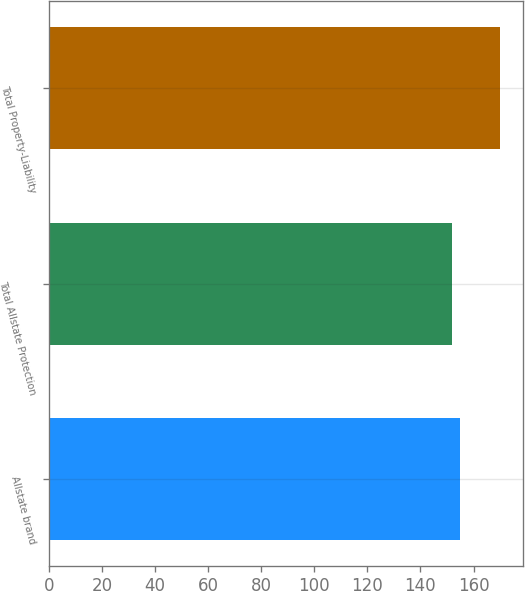<chart> <loc_0><loc_0><loc_500><loc_500><bar_chart><fcel>Allstate brand<fcel>Total Allstate Protection<fcel>Total Property-Liability<nl><fcel>155<fcel>152<fcel>170<nl></chart> 